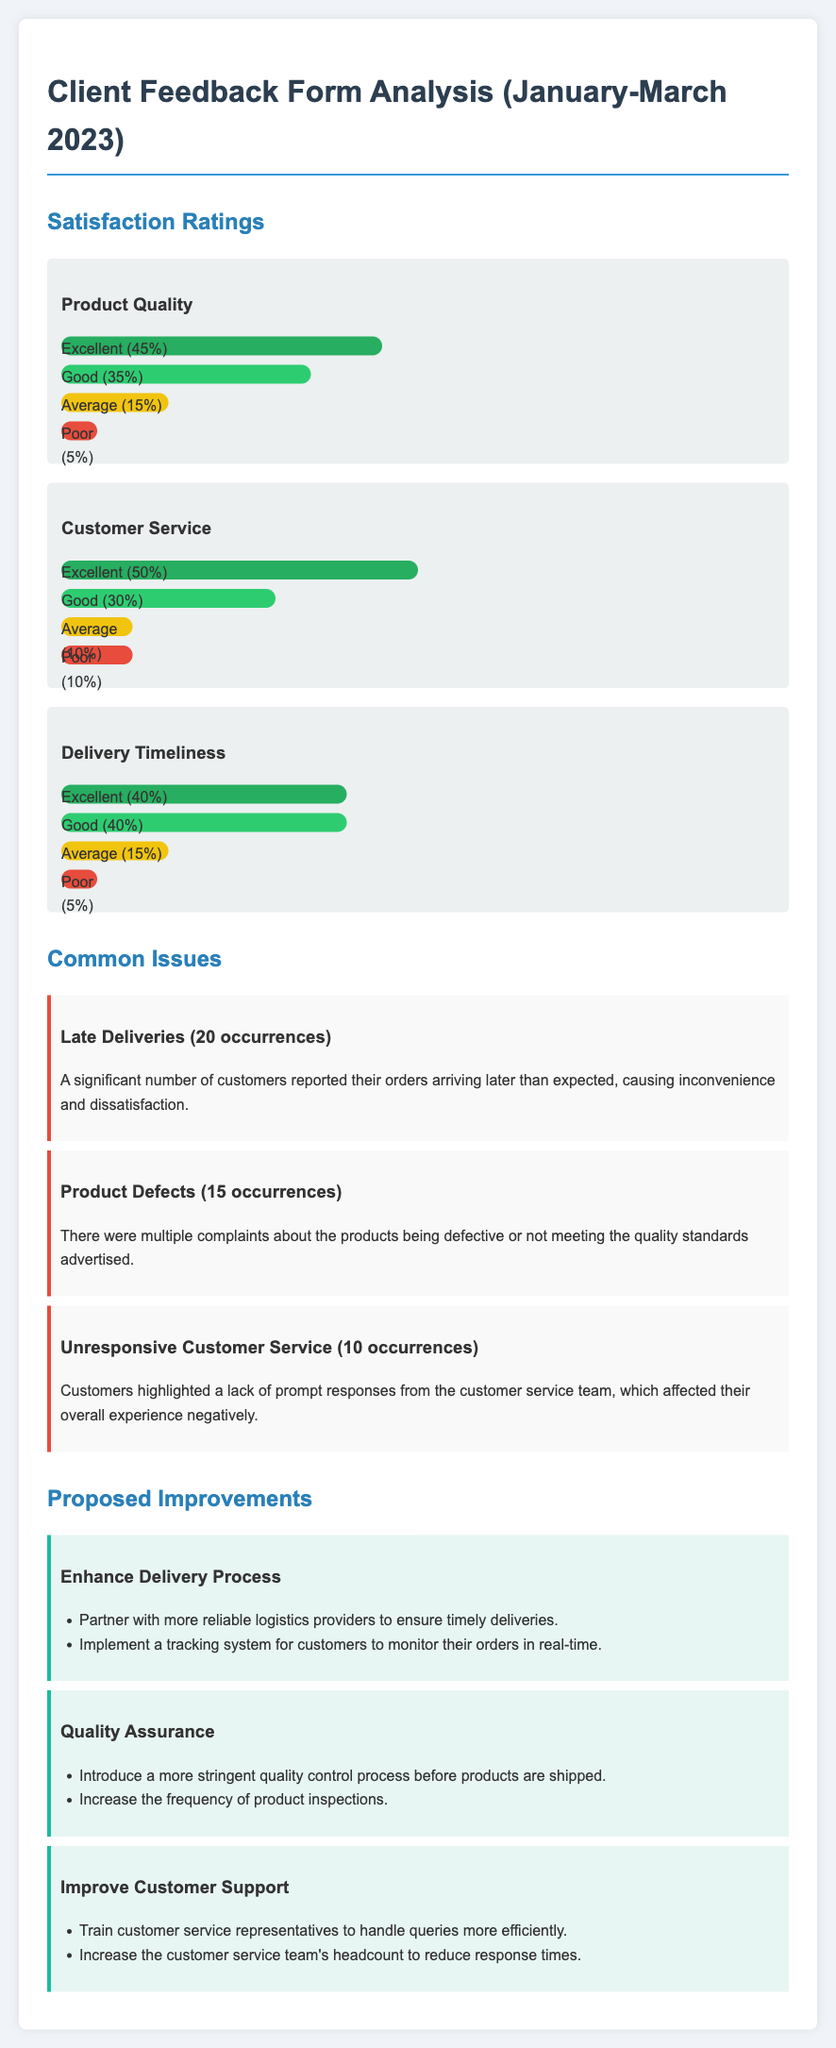what percentage of customers rated Product Quality as Excellent? The percentage of customers who rated Product Quality as Excellent is shown in the satisfaction ratings section of the document.
Answer: 45% how many occurrences were reported for Late Deliveries? The document lists the number of occurrences reported for Late Deliveries in the Common Issues section.
Answer: 20 occurrences what is the highest percentage rating for Customer Service? The highest percentage for Customer Service is marked in the satisfaction ratings.
Answer: 50% which improvement is proposed to enhance the quality of products? The proposed improvements for quality assurance detail the specific enhancements suggested in the document.
Answer: Introduce a more stringent quality control process how many complaints were made regarding Unresponsive Customer Service? The document provides the number of complaints related to Unresponsive Customer Service in the Common Issues section.
Answer: 10 occurrences what is the common issue with the most occurrences? The document indicates which issue has the most occurrences listed in the Common Issues section.
Answer: Late Deliveries how many satisfaction categories are detailed in the ratings? The satisfaction ratings section outlines different categories of ratings shown in the document.
Answer: 3 categories what is the second proposed improvement to customer support? The Proposed Improvements section outlines several suggestions for improving customer support.
Answer: Increase the customer service team's headcount 